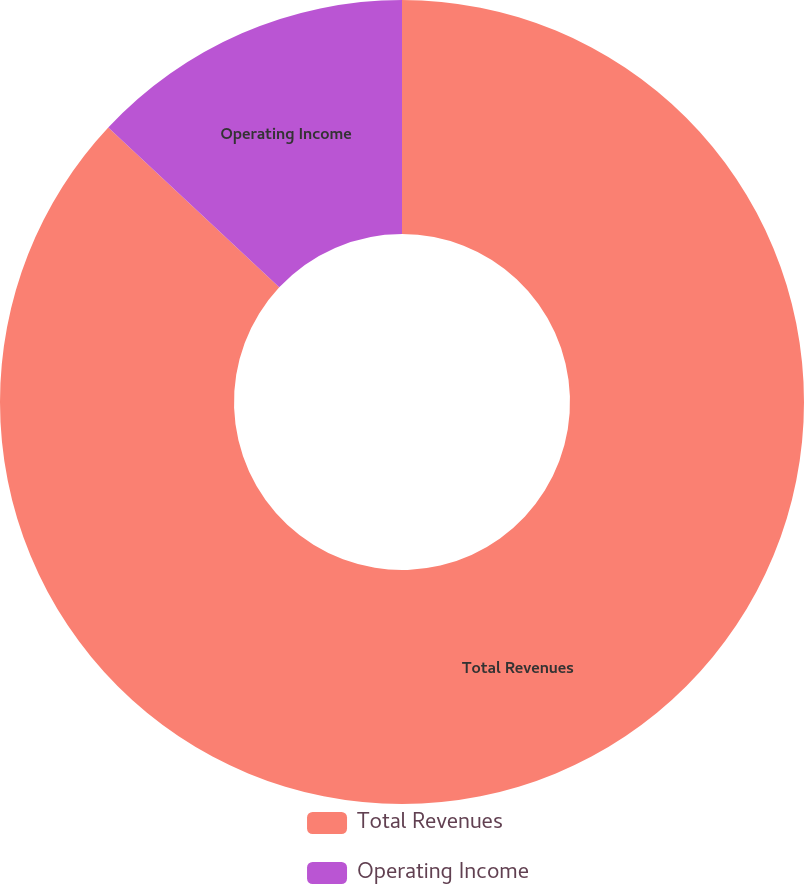<chart> <loc_0><loc_0><loc_500><loc_500><pie_chart><fcel>Total Revenues<fcel>Operating Income<nl><fcel>86.96%<fcel>13.04%<nl></chart> 